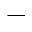Convert formula to latex. <formula><loc_0><loc_0><loc_500><loc_500>^ { - }</formula> 